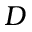<formula> <loc_0><loc_0><loc_500><loc_500>D</formula> 